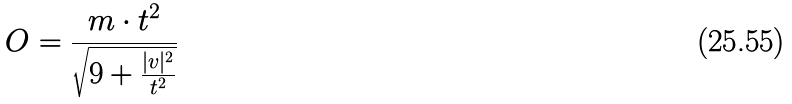Convert formula to latex. <formula><loc_0><loc_0><loc_500><loc_500>O = \frac { m \cdot t ^ { 2 } } { \sqrt { 9 + \frac { | v | ^ { 2 } } { t ^ { 2 } } } }</formula> 